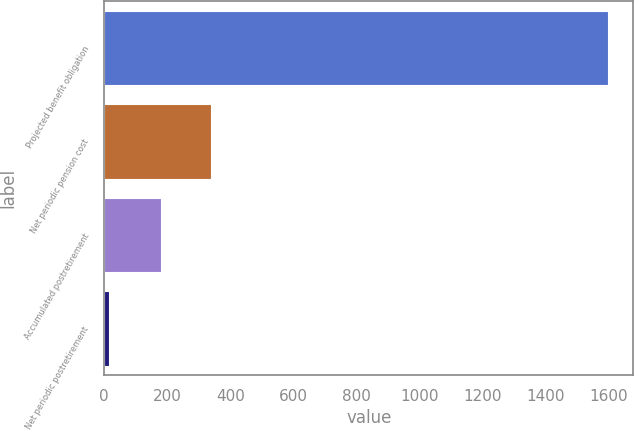Convert chart to OTSL. <chart><loc_0><loc_0><loc_500><loc_500><bar_chart><fcel>Projected benefit obligation<fcel>Net periodic pension cost<fcel>Accumulated postretirement<fcel>Net periodic postretirement<nl><fcel>1599<fcel>338.5<fcel>180<fcel>14<nl></chart> 